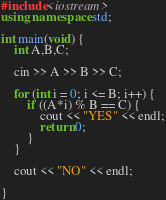<code> <loc_0><loc_0><loc_500><loc_500><_C++_>#include<iostream>
using namespace std;

int main(void) {
	int A,B,C;

	cin >> A >> B >> C;

	for (int i = 0; i <= B; i++) {
		if ((A*i) % B == C) {
			cout << "YES" << endl;
			return 0;
		}
	}

	cout << "NO" << endl;

}</code> 